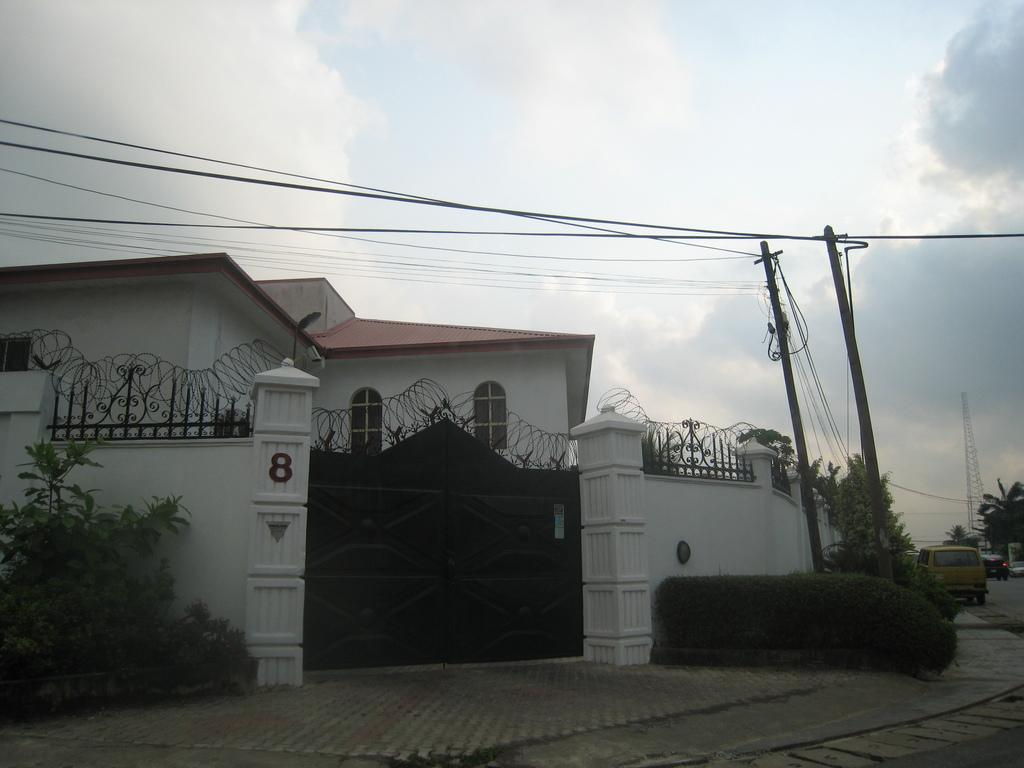What type of structure is visible in the image? There is a building in the image. What feature can be seen on the building? The building has windows. What is the entrance to the building like? There is a gate in the image. What type of vegetation is present in the image? There are trees in the image. What infrastructure elements are visible in the image? Current poles and wires are present in the image. What other tall structure is visible in the image? There is a tower in the image. What type of transportation is visible in the image? There are vehicles on the road in the image. What part of the natural environment is visible in the image? The sky is visible in the image. What type of office is located on the list in the image? There is no list or office present in the image. 